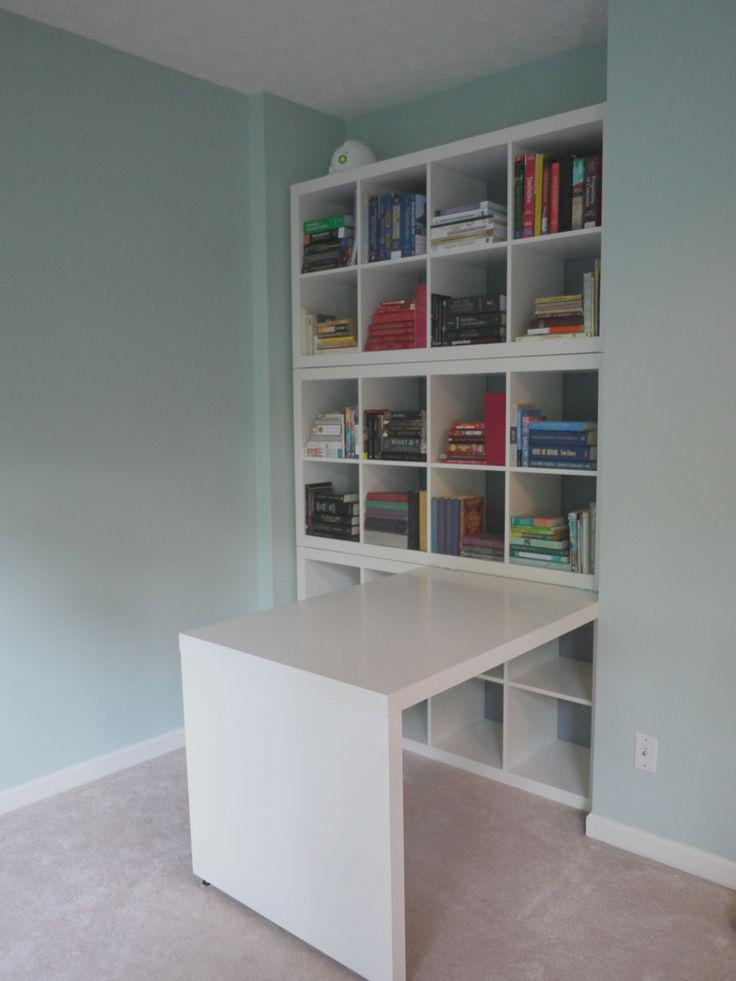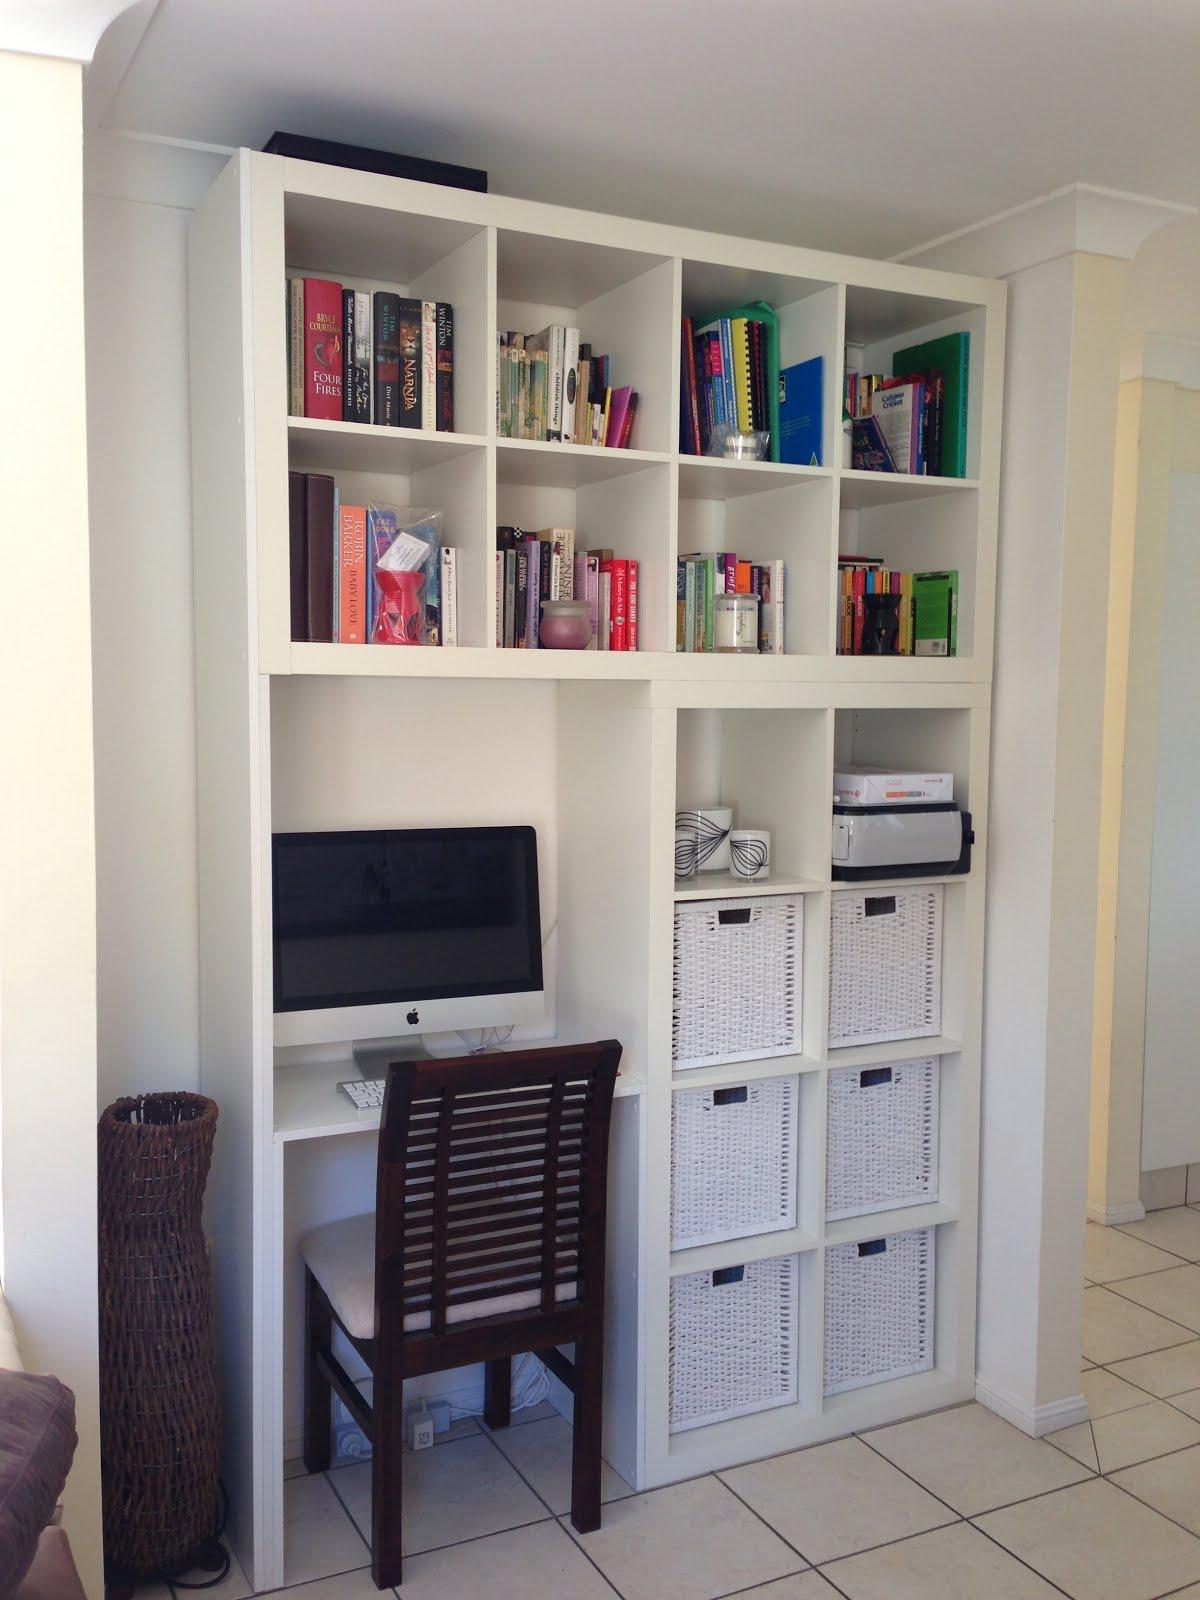The first image is the image on the left, the second image is the image on the right. Evaluate the accuracy of this statement regarding the images: "The left image shows a table that extends out from a bookshelf against a wall with divided square compartments containing some upright books.". Is it true? Answer yes or no. Yes. The first image is the image on the left, the second image is the image on the right. Evaluate the accuracy of this statement regarding the images: "At least one desk has a white surface.". Is it true? Answer yes or no. Yes. 